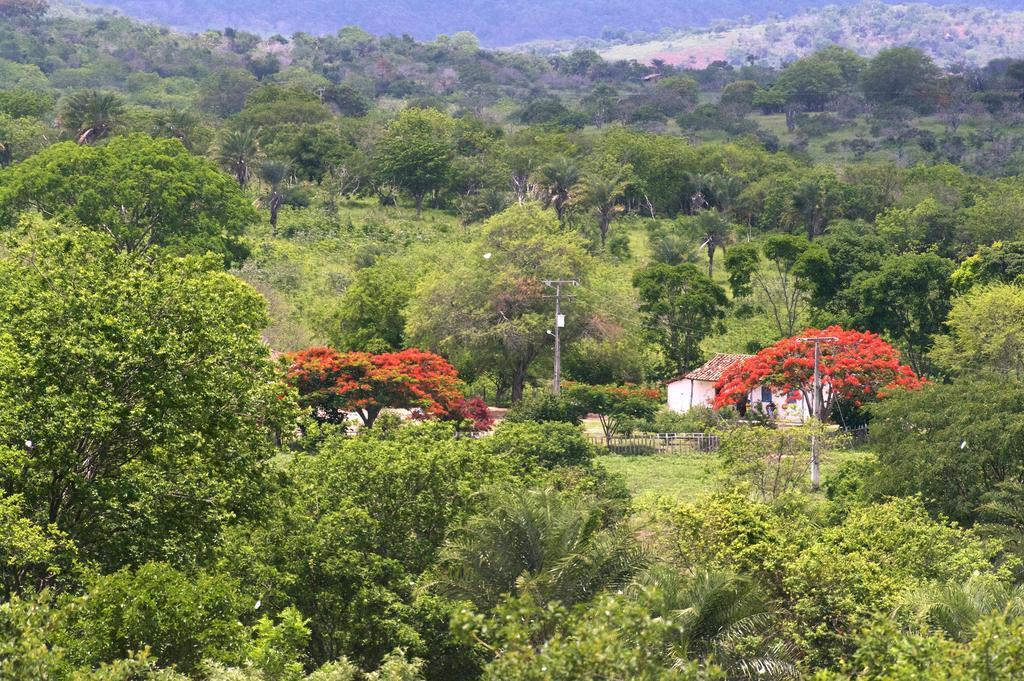What type of vegetation is present in the image? There are green trees in the image. What else can be seen in the image besides the trees? There are poles in the image. What type of oatmeal is being served in the image? There is no oatmeal present in the image. What type of leaf can be seen falling from the tree in the image? There is no leaf falling from the tree in the image. 